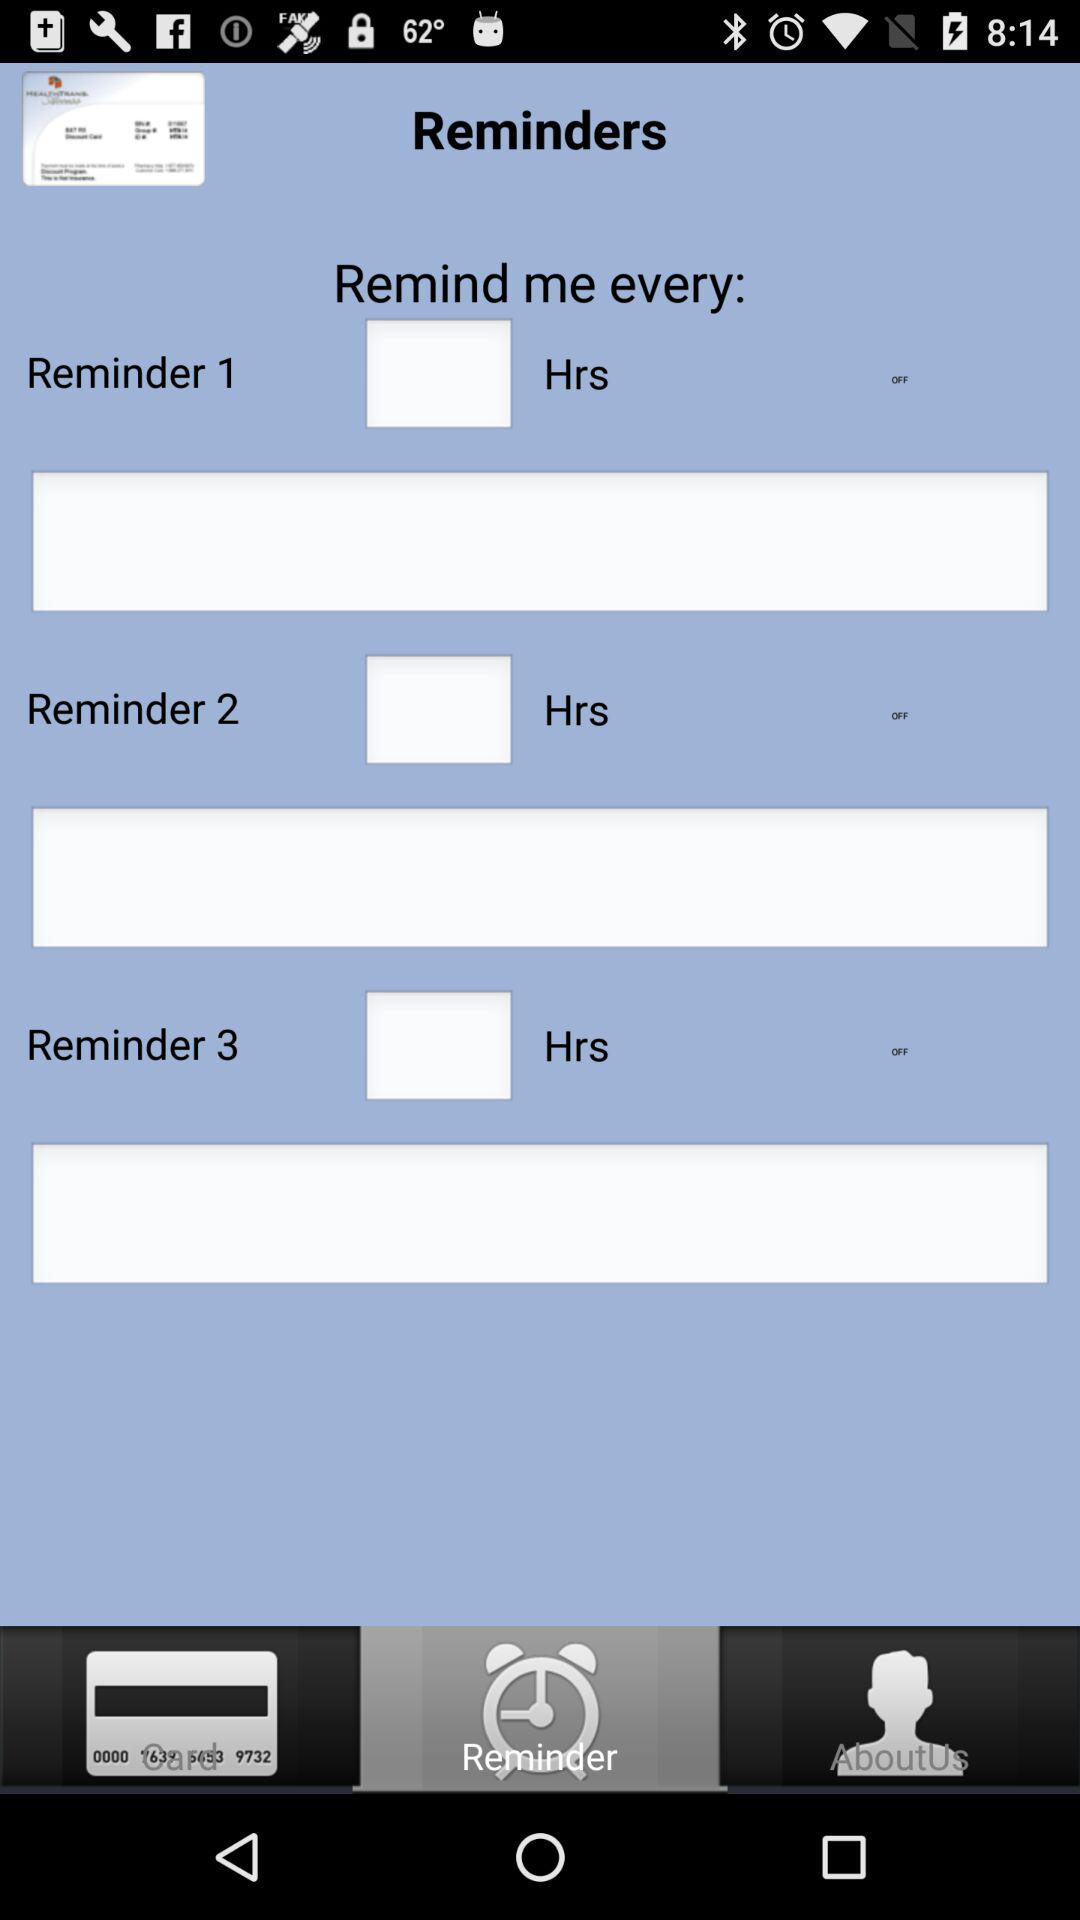Which tab is selected? The selected tab is "Reminder". 